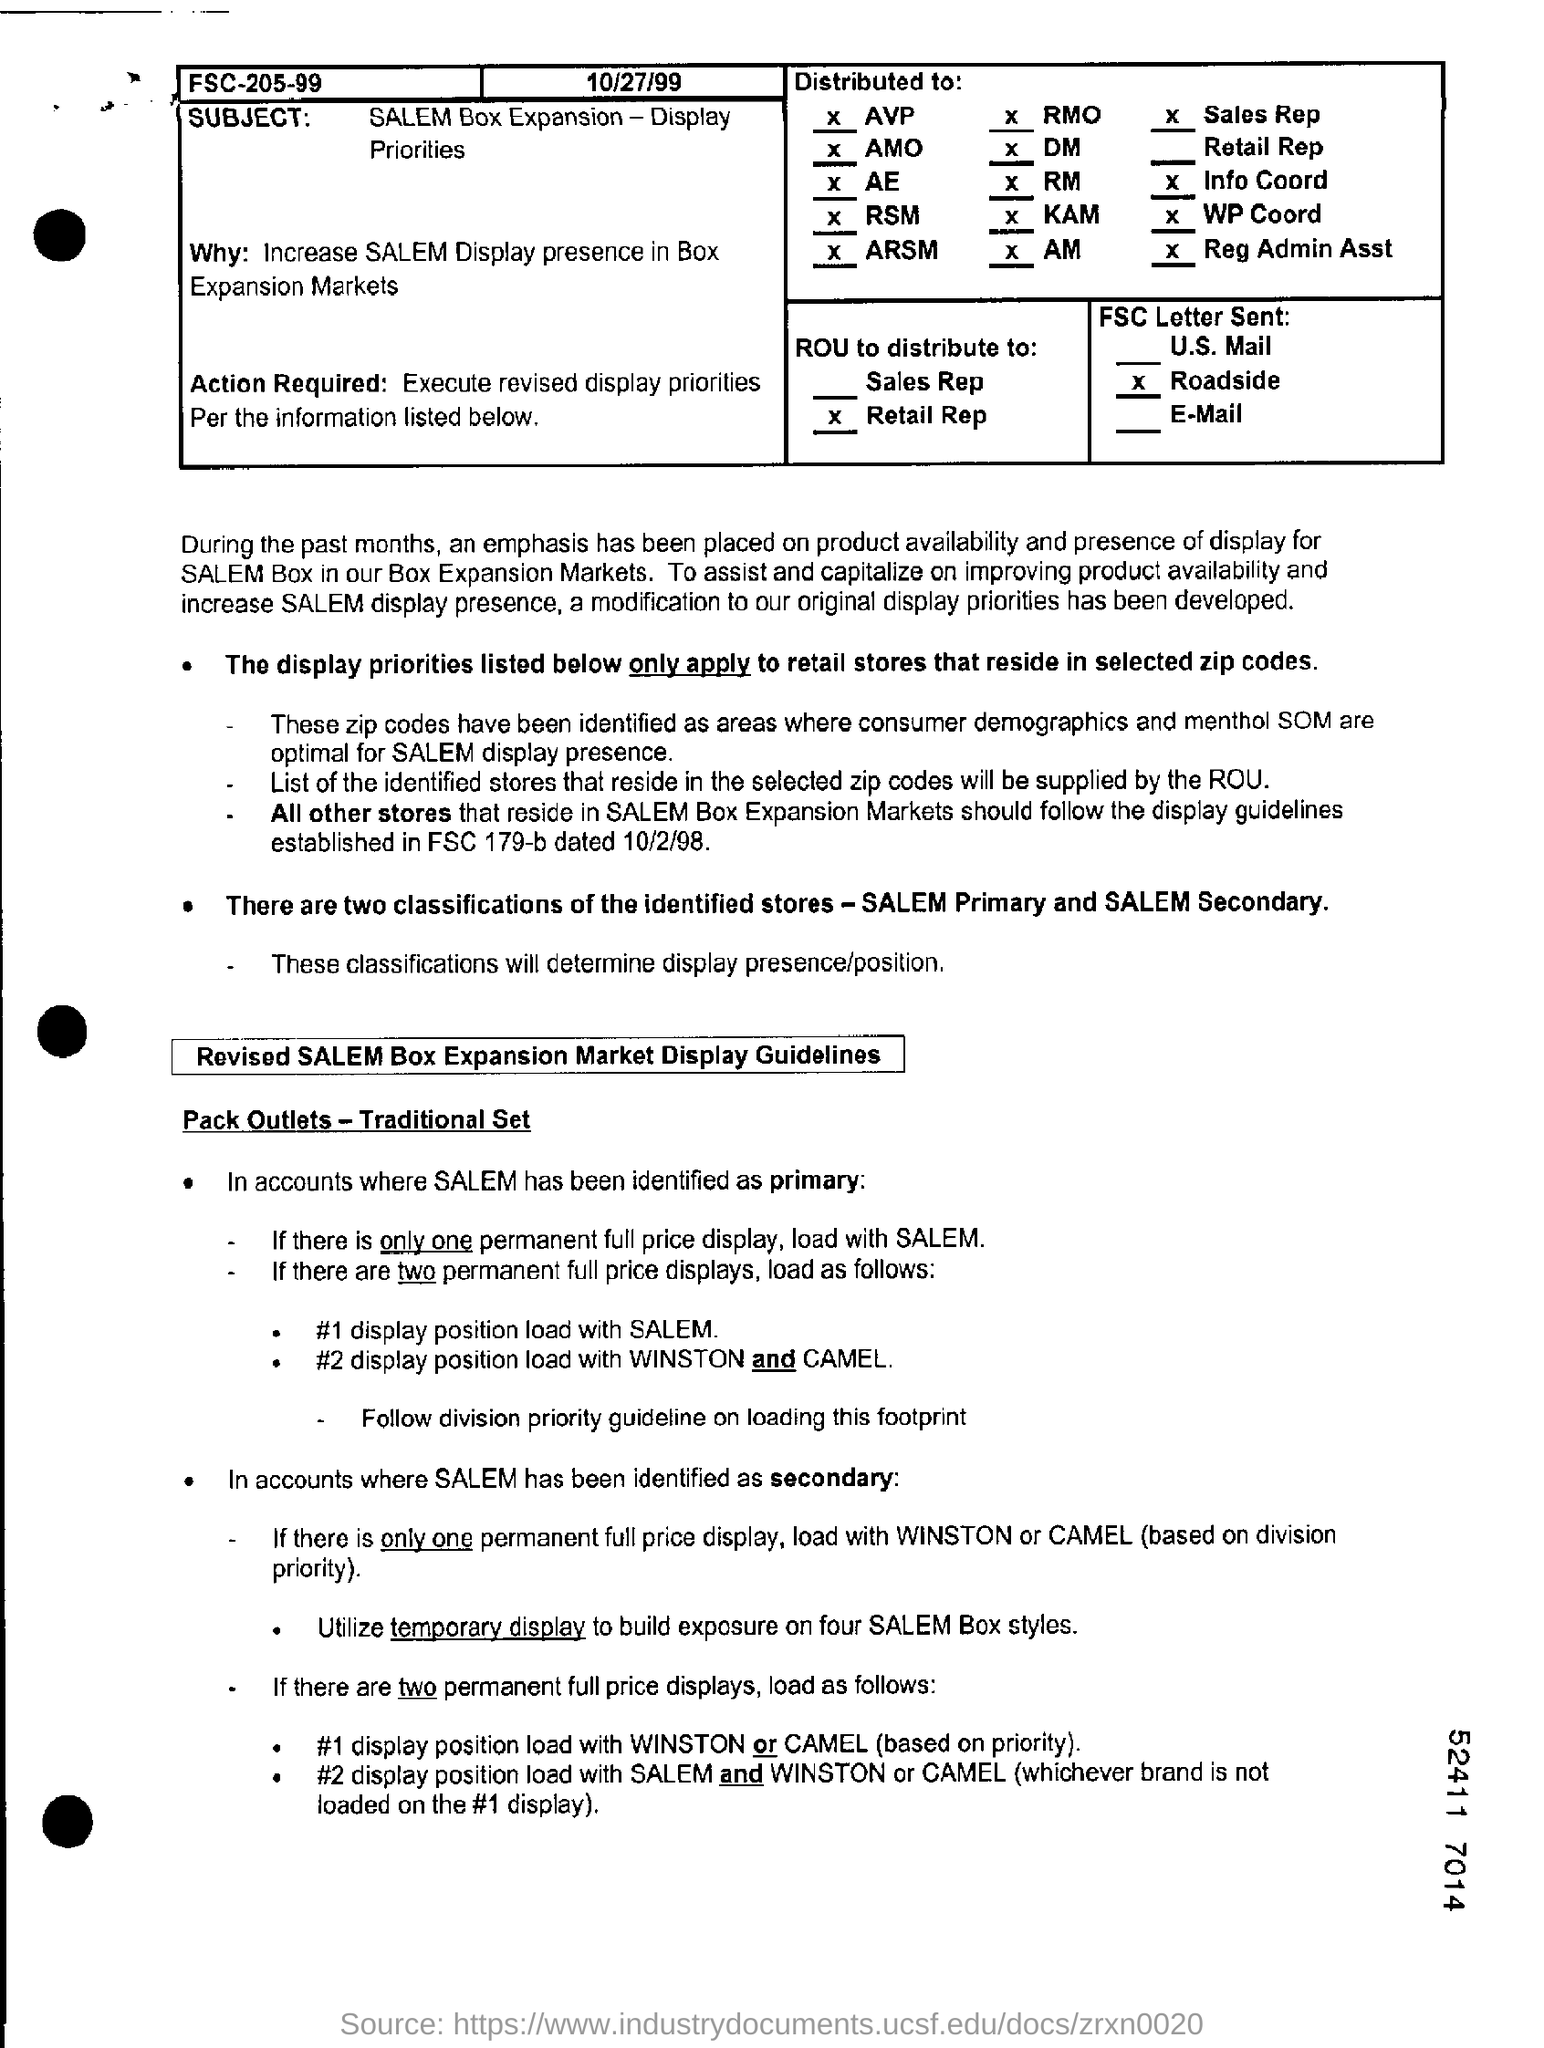What is the subject?
Offer a very short reply. SALEM Box Expansion - Display Priorities. What are two classifications of identified stores?
Offer a terse response. SALEM primary and SALEM secondary. What is the date mentioned?
Ensure brevity in your answer.  10/27/99. 